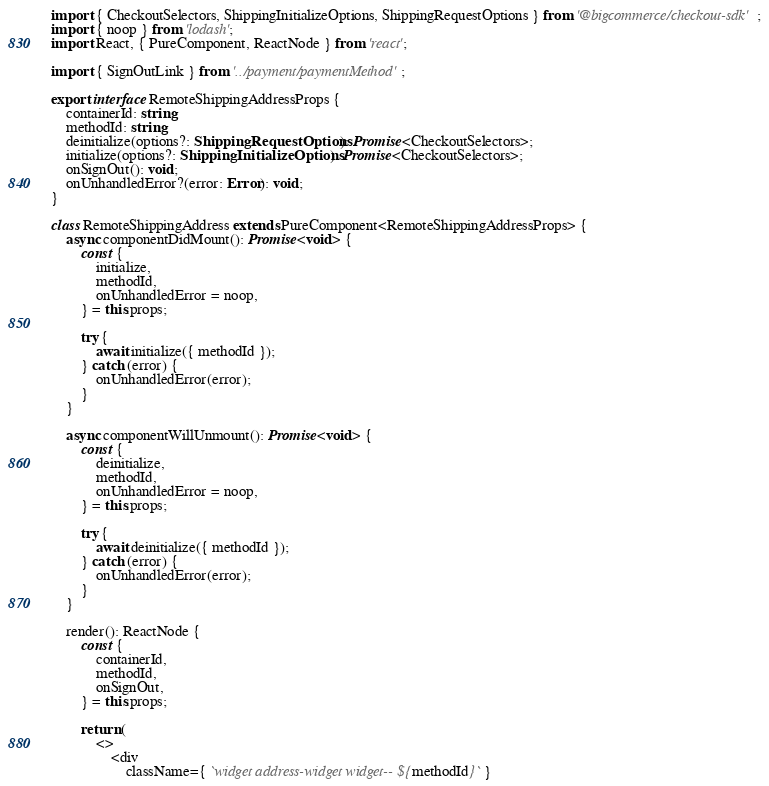<code> <loc_0><loc_0><loc_500><loc_500><_TypeScript_>import { CheckoutSelectors, ShippingInitializeOptions, ShippingRequestOptions } from '@bigcommerce/checkout-sdk';
import { noop } from 'lodash';
import React, { PureComponent, ReactNode } from 'react';

import { SignOutLink } from '../payment/paymentMethod';

export interface RemoteShippingAddressProps {
    containerId: string;
    methodId: string;
    deinitialize(options?: ShippingRequestOptions): Promise<CheckoutSelectors>;
    initialize(options?: ShippingInitializeOptions): Promise<CheckoutSelectors>;
    onSignOut(): void;
    onUnhandledError?(error: Error): void;
}

class RemoteShippingAddress extends PureComponent<RemoteShippingAddressProps> {
    async componentDidMount(): Promise<void> {
        const {
            initialize,
            methodId,
            onUnhandledError = noop,
        } = this.props;

        try {
            await initialize({ methodId });
        } catch (error) {
            onUnhandledError(error);
        }
    }

    async componentWillUnmount(): Promise<void> {
        const {
            deinitialize,
            methodId,
            onUnhandledError = noop,
        } = this.props;

        try {
            await deinitialize({ methodId });
        } catch (error) {
            onUnhandledError(error);
        }
    }

    render(): ReactNode {
        const {
            containerId,
            methodId,
            onSignOut,
        } = this.props;

        return (
            <>
                <div
                    className={ `widget address-widget widget--${methodId}` }</code> 